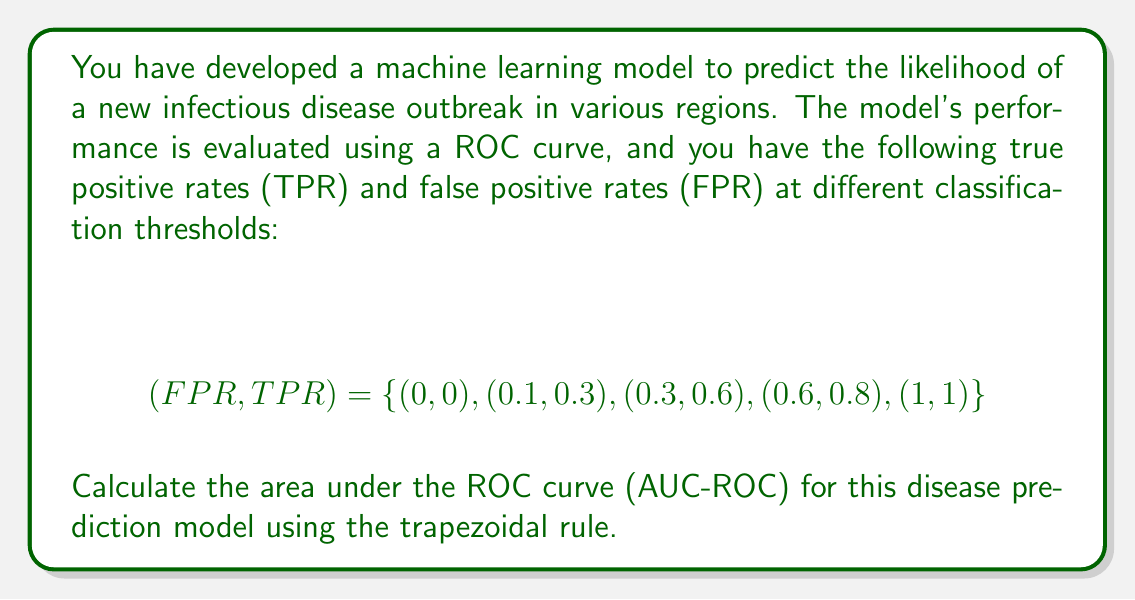Give your solution to this math problem. To calculate the area under the ROC curve (AUC-ROC) using the trapezoidal rule, we need to:

1. Order the points by increasing FPR (which they already are in this case).
2. Calculate the area of each trapezoid formed by adjacent points.
3. Sum all the trapezoid areas.

The formula for the area of a trapezoid is:

$$A = \frac{1}{2}(b_1 + b_2)h$$

where $b_1$ and $b_2$ are the parallel sides (in our case, the TPR values), and $h$ is the height (the difference in FPR values).

Let's calculate the area for each trapezoid:

1. Between (0, 0) and (0.1, 0.3):
   $$A_1 = \frac{1}{2}(0 + 0.3)(0.1 - 0) = 0.015$$

2. Between (0.1, 0.3) and (0.3, 0.6):
   $$A_2 = \frac{1}{2}(0.3 + 0.6)(0.3 - 0.1) = 0.09$$

3. Between (0.3, 0.6) and (0.6, 0.8):
   $$A_3 = \frac{1}{2}(0.6 + 0.8)(0.6 - 0.3) = 0.21$$

4. Between (0.6, 0.8) and (1, 1):
   $$A_4 = \frac{1}{2}(0.8 + 1)(1 - 0.6) = 0.36$$

Now, we sum all these areas:

$$AUC-ROC = A_1 + A_2 + A_3 + A_4 = 0.015 + 0.09 + 0.21 + 0.36 = 0.675$$
Answer: The area under the ROC curve (AUC-ROC) for the disease prediction model is 0.675. 